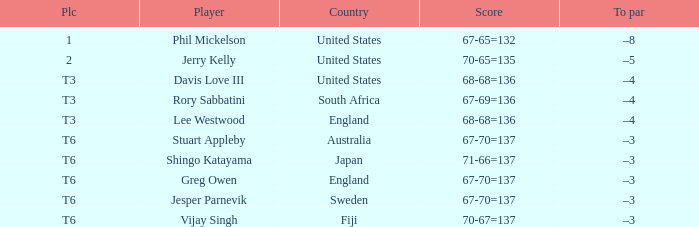Identify the score of vijay singh. 70-67=137. 